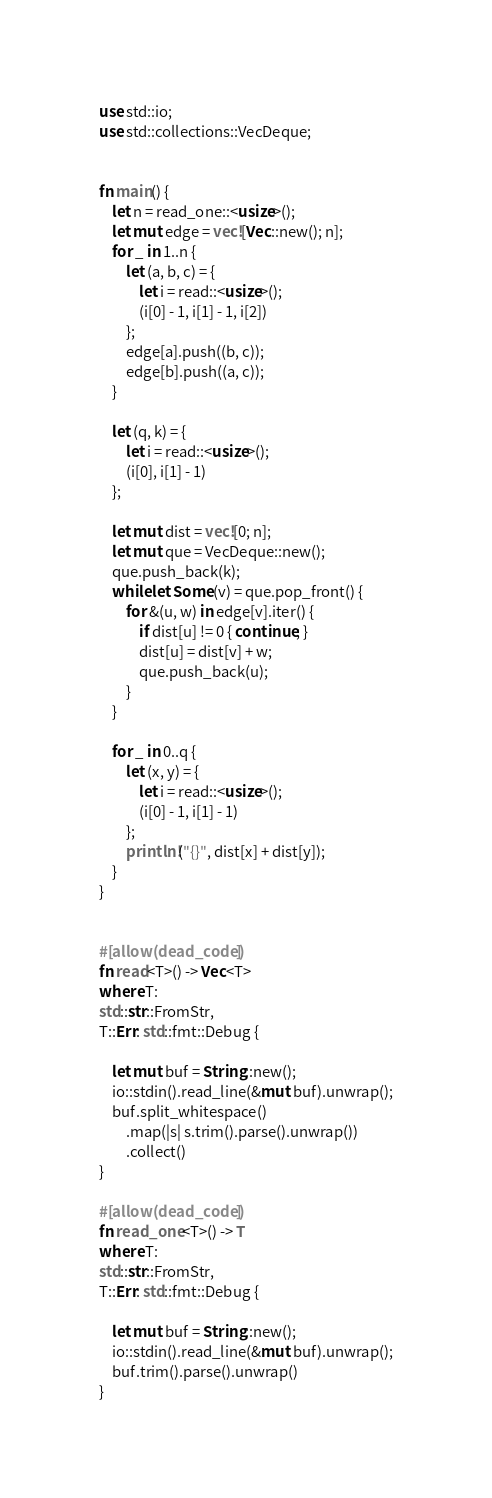<code> <loc_0><loc_0><loc_500><loc_500><_Rust_>use std::io;
use std::collections::VecDeque;


fn main() {
    let n = read_one::<usize>();
    let mut edge = vec![Vec::new(); n];
    for _ in 1..n {
        let (a, b, c) = {
            let i = read::<usize>();
            (i[0] - 1, i[1] - 1, i[2])
        };
        edge[a].push((b, c));
        edge[b].push((a, c));
    }

    let (q, k) = {
        let i = read::<usize>();
        (i[0], i[1] - 1)
    };

    let mut dist = vec![0; n];
    let mut que = VecDeque::new();
    que.push_back(k);
    while let Some(v) = que.pop_front() {
        for &(u, w) in edge[v].iter() {
            if dist[u] != 0 { continue; }
            dist[u] = dist[v] + w;
            que.push_back(u);
        }
    }

    for _ in 0..q {
        let (x, y) = {
            let i = read::<usize>();
            (i[0] - 1, i[1] - 1)
        };
        println!("{}", dist[x] + dist[y]);
    }
}


#[allow(dead_code)]
fn read<T>() -> Vec<T>
where T:
std::str::FromStr,
T::Err: std::fmt::Debug {

    let mut buf = String::new();
    io::stdin().read_line(&mut buf).unwrap();
    buf.split_whitespace()
        .map(|s| s.trim().parse().unwrap())
        .collect()
}

#[allow(dead_code)]
fn read_one<T>() -> T
where T:
std::str::FromStr,
T::Err: std::fmt::Debug {

    let mut buf = String::new();
    io::stdin().read_line(&mut buf).unwrap();
    buf.trim().parse().unwrap()
}</code> 